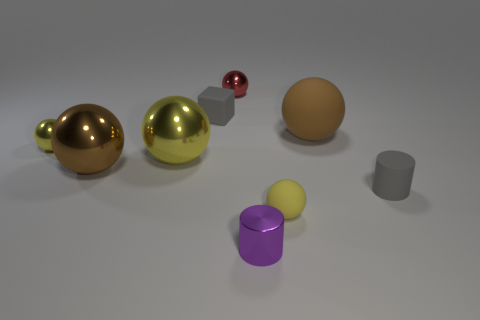Are there more small yellow things that are behind the block than large matte balls?
Give a very brief answer. No. What is the color of the small metal cylinder?
Keep it short and to the point. Purple. There is a brown thing that is to the right of the large yellow sphere that is to the left of the gray rubber object to the left of the brown rubber thing; what shape is it?
Make the answer very short. Sphere. There is a ball that is both left of the tiny red thing and behind the large yellow thing; what material is it?
Keep it short and to the point. Metal. There is a yellow thing that is in front of the cylinder right of the small yellow matte object; what shape is it?
Provide a succinct answer. Sphere. Is there anything else that has the same color as the small matte cube?
Ensure brevity in your answer.  Yes. There is a gray rubber cylinder; does it have the same size as the brown rubber sphere behind the small gray rubber cylinder?
Offer a very short reply. No. What number of small things are blocks or purple shiny objects?
Your answer should be compact. 2. Are there more purple objects than small metallic spheres?
Provide a short and direct response. No. There is a big brown thing right of the gray thing on the left side of the yellow rubber ball; what number of brown rubber objects are to the right of it?
Keep it short and to the point. 0. 